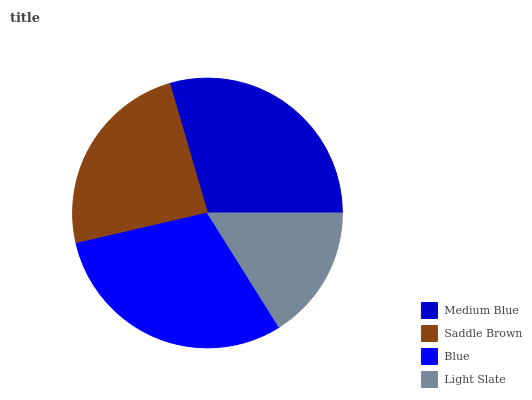Is Light Slate the minimum?
Answer yes or no. Yes. Is Blue the maximum?
Answer yes or no. Yes. Is Saddle Brown the minimum?
Answer yes or no. No. Is Saddle Brown the maximum?
Answer yes or no. No. Is Medium Blue greater than Saddle Brown?
Answer yes or no. Yes. Is Saddle Brown less than Medium Blue?
Answer yes or no. Yes. Is Saddle Brown greater than Medium Blue?
Answer yes or no. No. Is Medium Blue less than Saddle Brown?
Answer yes or no. No. Is Medium Blue the high median?
Answer yes or no. Yes. Is Saddle Brown the low median?
Answer yes or no. Yes. Is Blue the high median?
Answer yes or no. No. Is Blue the low median?
Answer yes or no. No. 